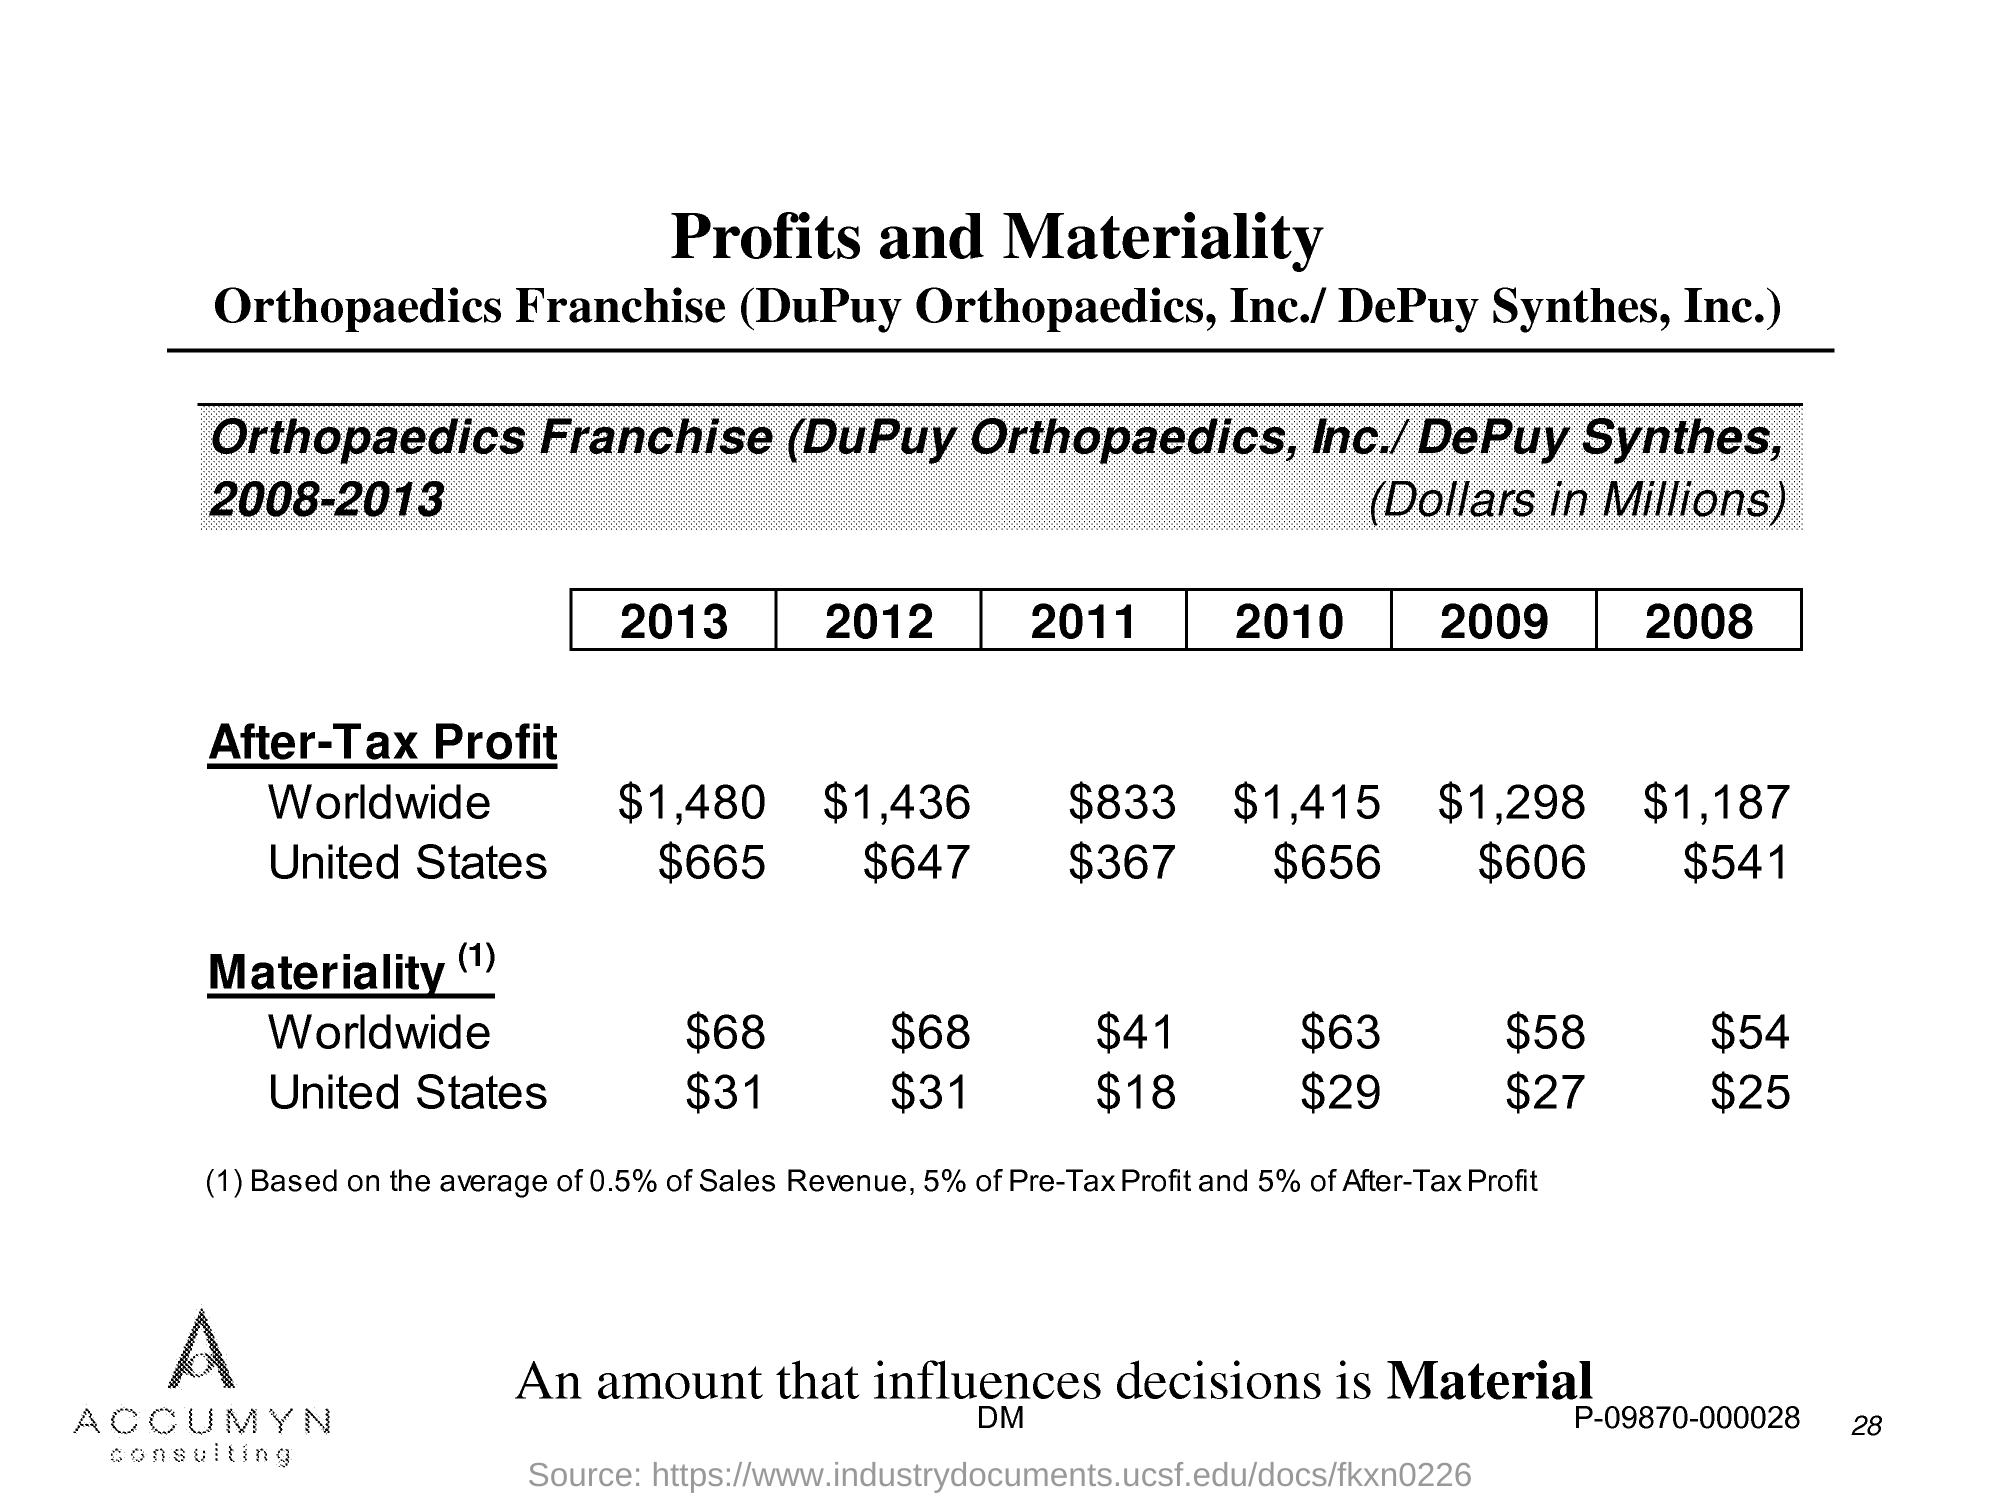Draw attention to some important aspects in this diagram. In the year 2009, the after-tax profit worldwide was $1,298. The after-tax profit worldwide in the year 2008 was $1,187. The after-tax profit of the United States in the year 2013 was $665 million. The after-tax profit worldwide in the year 2012 was $1,436. After-tax profit worldwide in the year 2011 was approximately $833. 